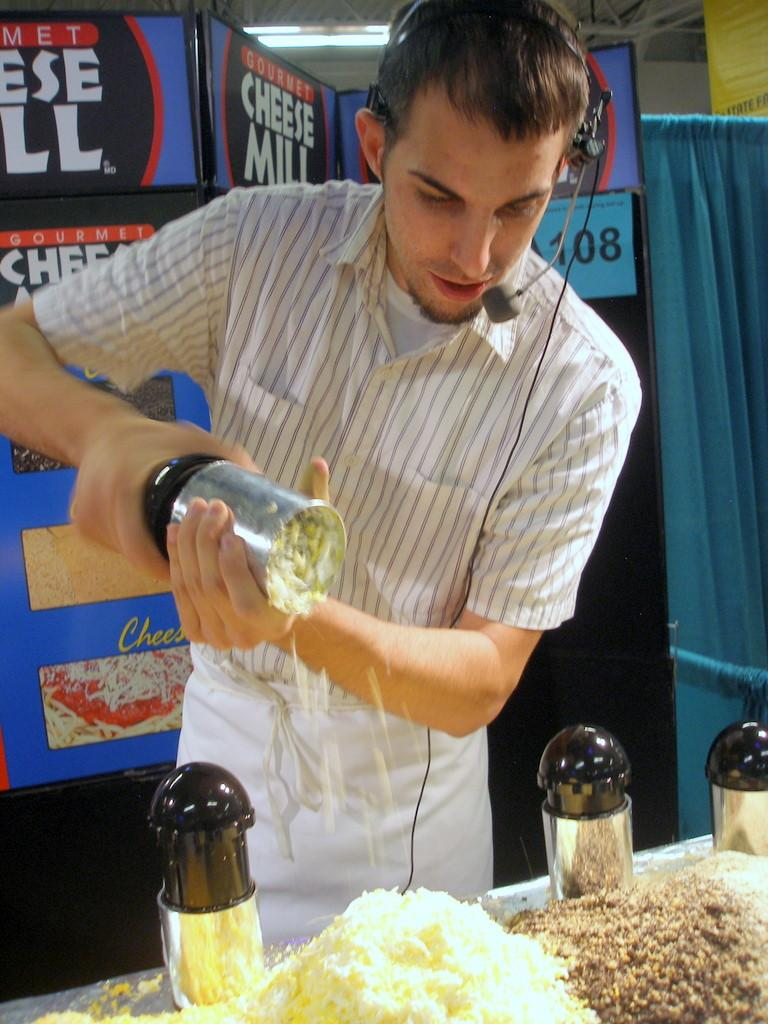<image>
Relay a brief, clear account of the picture shown. a man wearing a microphone with a sign for cheese behind him 